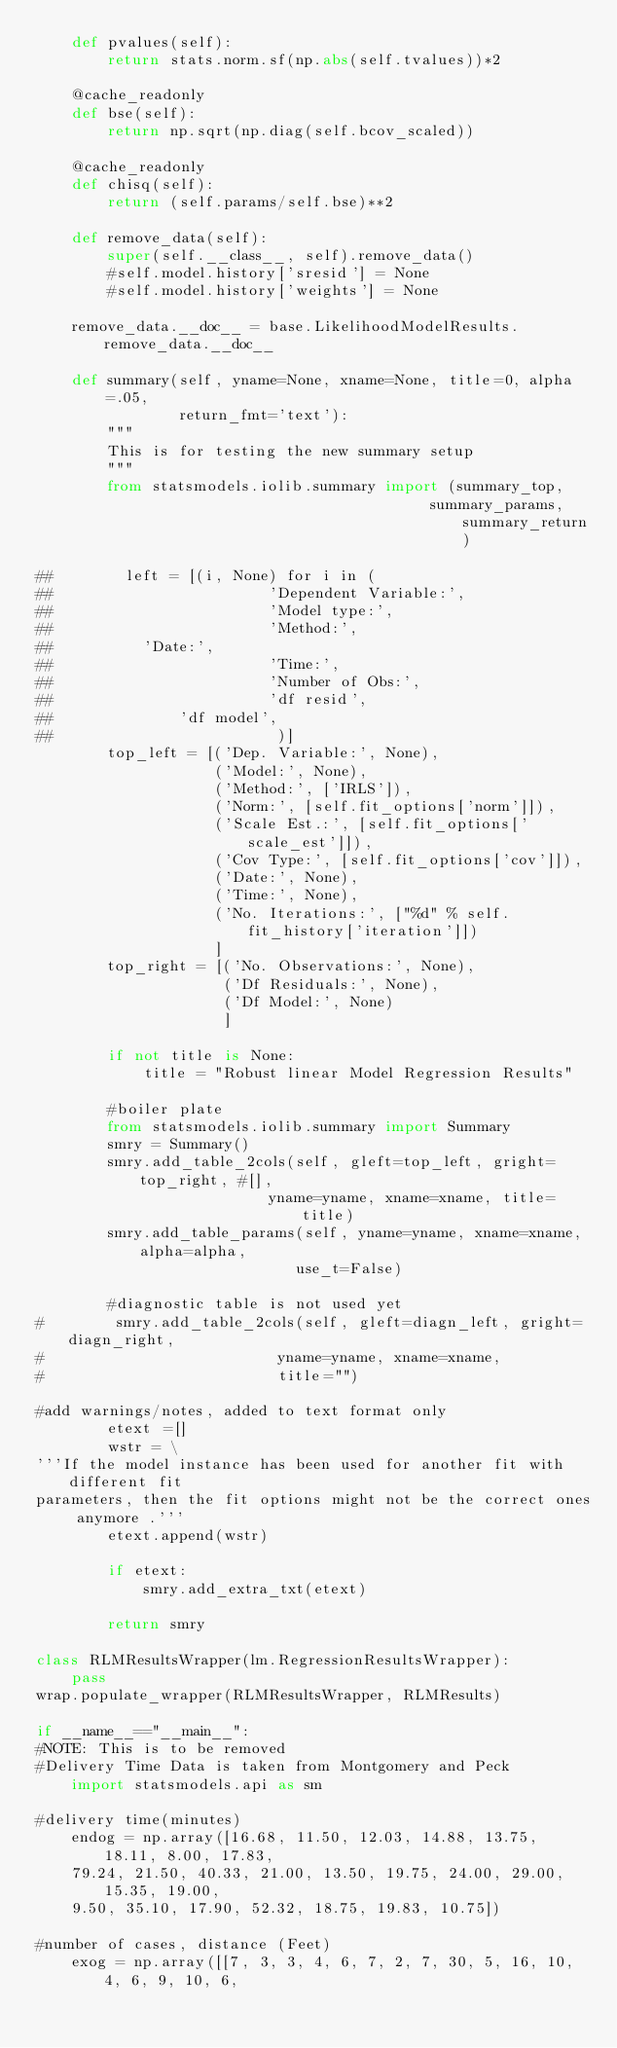<code> <loc_0><loc_0><loc_500><loc_500><_Python_>    def pvalues(self):
        return stats.norm.sf(np.abs(self.tvalues))*2

    @cache_readonly
    def bse(self):
        return np.sqrt(np.diag(self.bcov_scaled))

    @cache_readonly
    def chisq(self):
        return (self.params/self.bse)**2

    def remove_data(self):
        super(self.__class__, self).remove_data()
        #self.model.history['sresid'] = None
        #self.model.history['weights'] = None

    remove_data.__doc__ = base.LikelihoodModelResults.remove_data.__doc__

    def summary(self, yname=None, xname=None, title=0, alpha=.05,
                return_fmt='text'):
        """
        This is for testing the new summary setup
        """
        from statsmodels.iolib.summary import (summary_top,
                                            summary_params, summary_return)

##        left = [(i, None) for i in (
##                        'Dependent Variable:',
##                        'Model type:',
##                        'Method:',
##			'Date:',
##                        'Time:',
##                        'Number of Obs:',
##                        'df resid',
##		        'df model',
##                         )]
        top_left = [('Dep. Variable:', None),
                    ('Model:', None),
                    ('Method:', ['IRLS']),
                    ('Norm:', [self.fit_options['norm']]),
                    ('Scale Est.:', [self.fit_options['scale_est']]),
                    ('Cov Type:', [self.fit_options['cov']]),
                    ('Date:', None),
                    ('Time:', None),
                    ('No. Iterations:', ["%d" % self.fit_history['iteration']])
                    ]
        top_right = [('No. Observations:', None),
                     ('Df Residuals:', None),
                     ('Df Model:', None)
                     ]

        if not title is None:
            title = "Robust linear Model Regression Results"

        #boiler plate
        from statsmodels.iolib.summary import Summary
        smry = Summary()
        smry.add_table_2cols(self, gleft=top_left, gright=top_right, #[],
                          yname=yname, xname=xname, title=title)
        smry.add_table_params(self, yname=yname, xname=xname, alpha=alpha,
                             use_t=False)

        #diagnostic table is not used yet
#        smry.add_table_2cols(self, gleft=diagn_left, gright=diagn_right,
#                          yname=yname, xname=xname,
#                          title="")

#add warnings/notes, added to text format only
        etext =[]
        wstr = \
'''If the model instance has been used for another fit with different fit
parameters, then the fit options might not be the correct ones anymore .'''
        etext.append(wstr)

        if etext:
            smry.add_extra_txt(etext)

        return smry

class RLMResultsWrapper(lm.RegressionResultsWrapper):
    pass
wrap.populate_wrapper(RLMResultsWrapper, RLMResults)

if __name__=="__main__":
#NOTE: This is to be removed
#Delivery Time Data is taken from Montgomery and Peck
    import statsmodels.api as sm

#delivery time(minutes)
    endog = np.array([16.68, 11.50, 12.03, 14.88, 13.75, 18.11, 8.00, 17.83,
    79.24, 21.50, 40.33, 21.00, 13.50, 19.75, 24.00, 29.00, 15.35, 19.00,
    9.50, 35.10, 17.90, 52.32, 18.75, 19.83, 10.75])

#number of cases, distance (Feet)
    exog = np.array([[7, 3, 3, 4, 6, 7, 2, 7, 30, 5, 16, 10, 4, 6, 9, 10, 6,</code> 